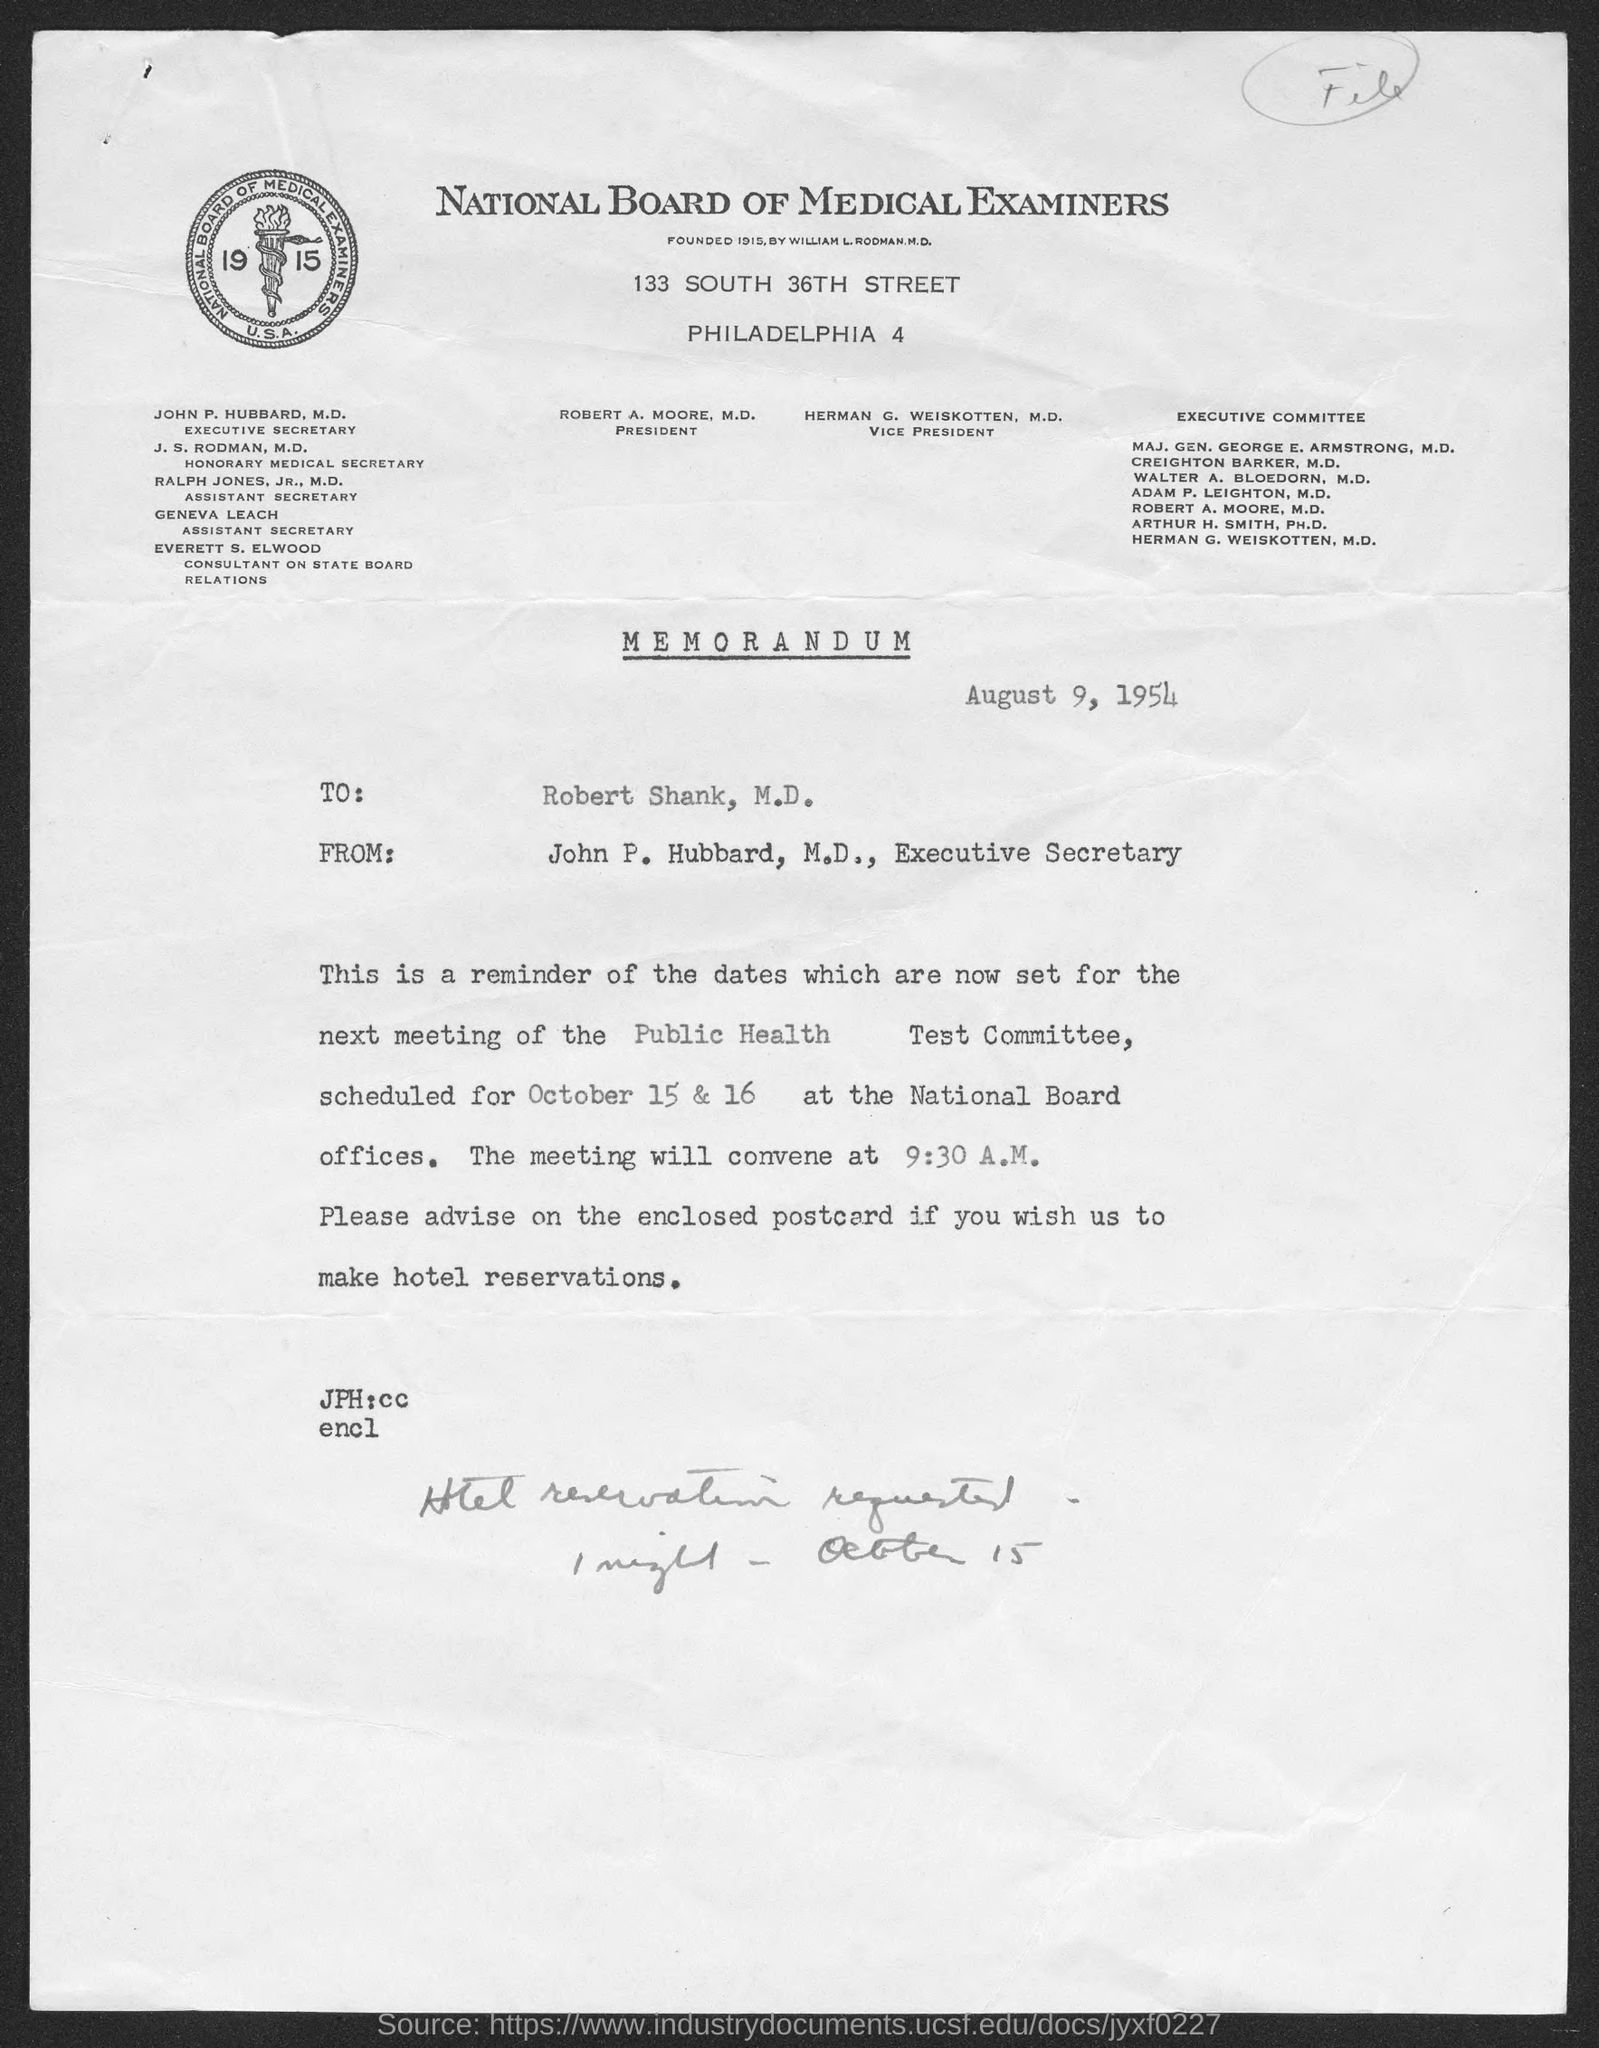Outline some significant characteristics in this image. The position of Ralph Jones, Jr., M.D. is Assistant Secretary. The person named Geneva Leach holds the position of Assistant Secretary. John P. Hubbard, M.D. holds the position of Executive Secretary. The National Board of Medical Examiners was founded by William L. Rodman, M.D. The memorandum is dated August 9, 1954. 